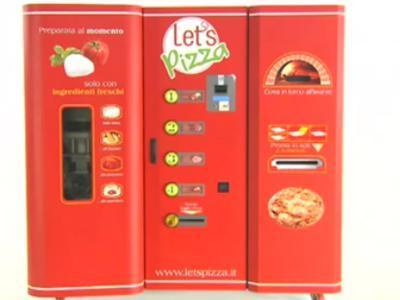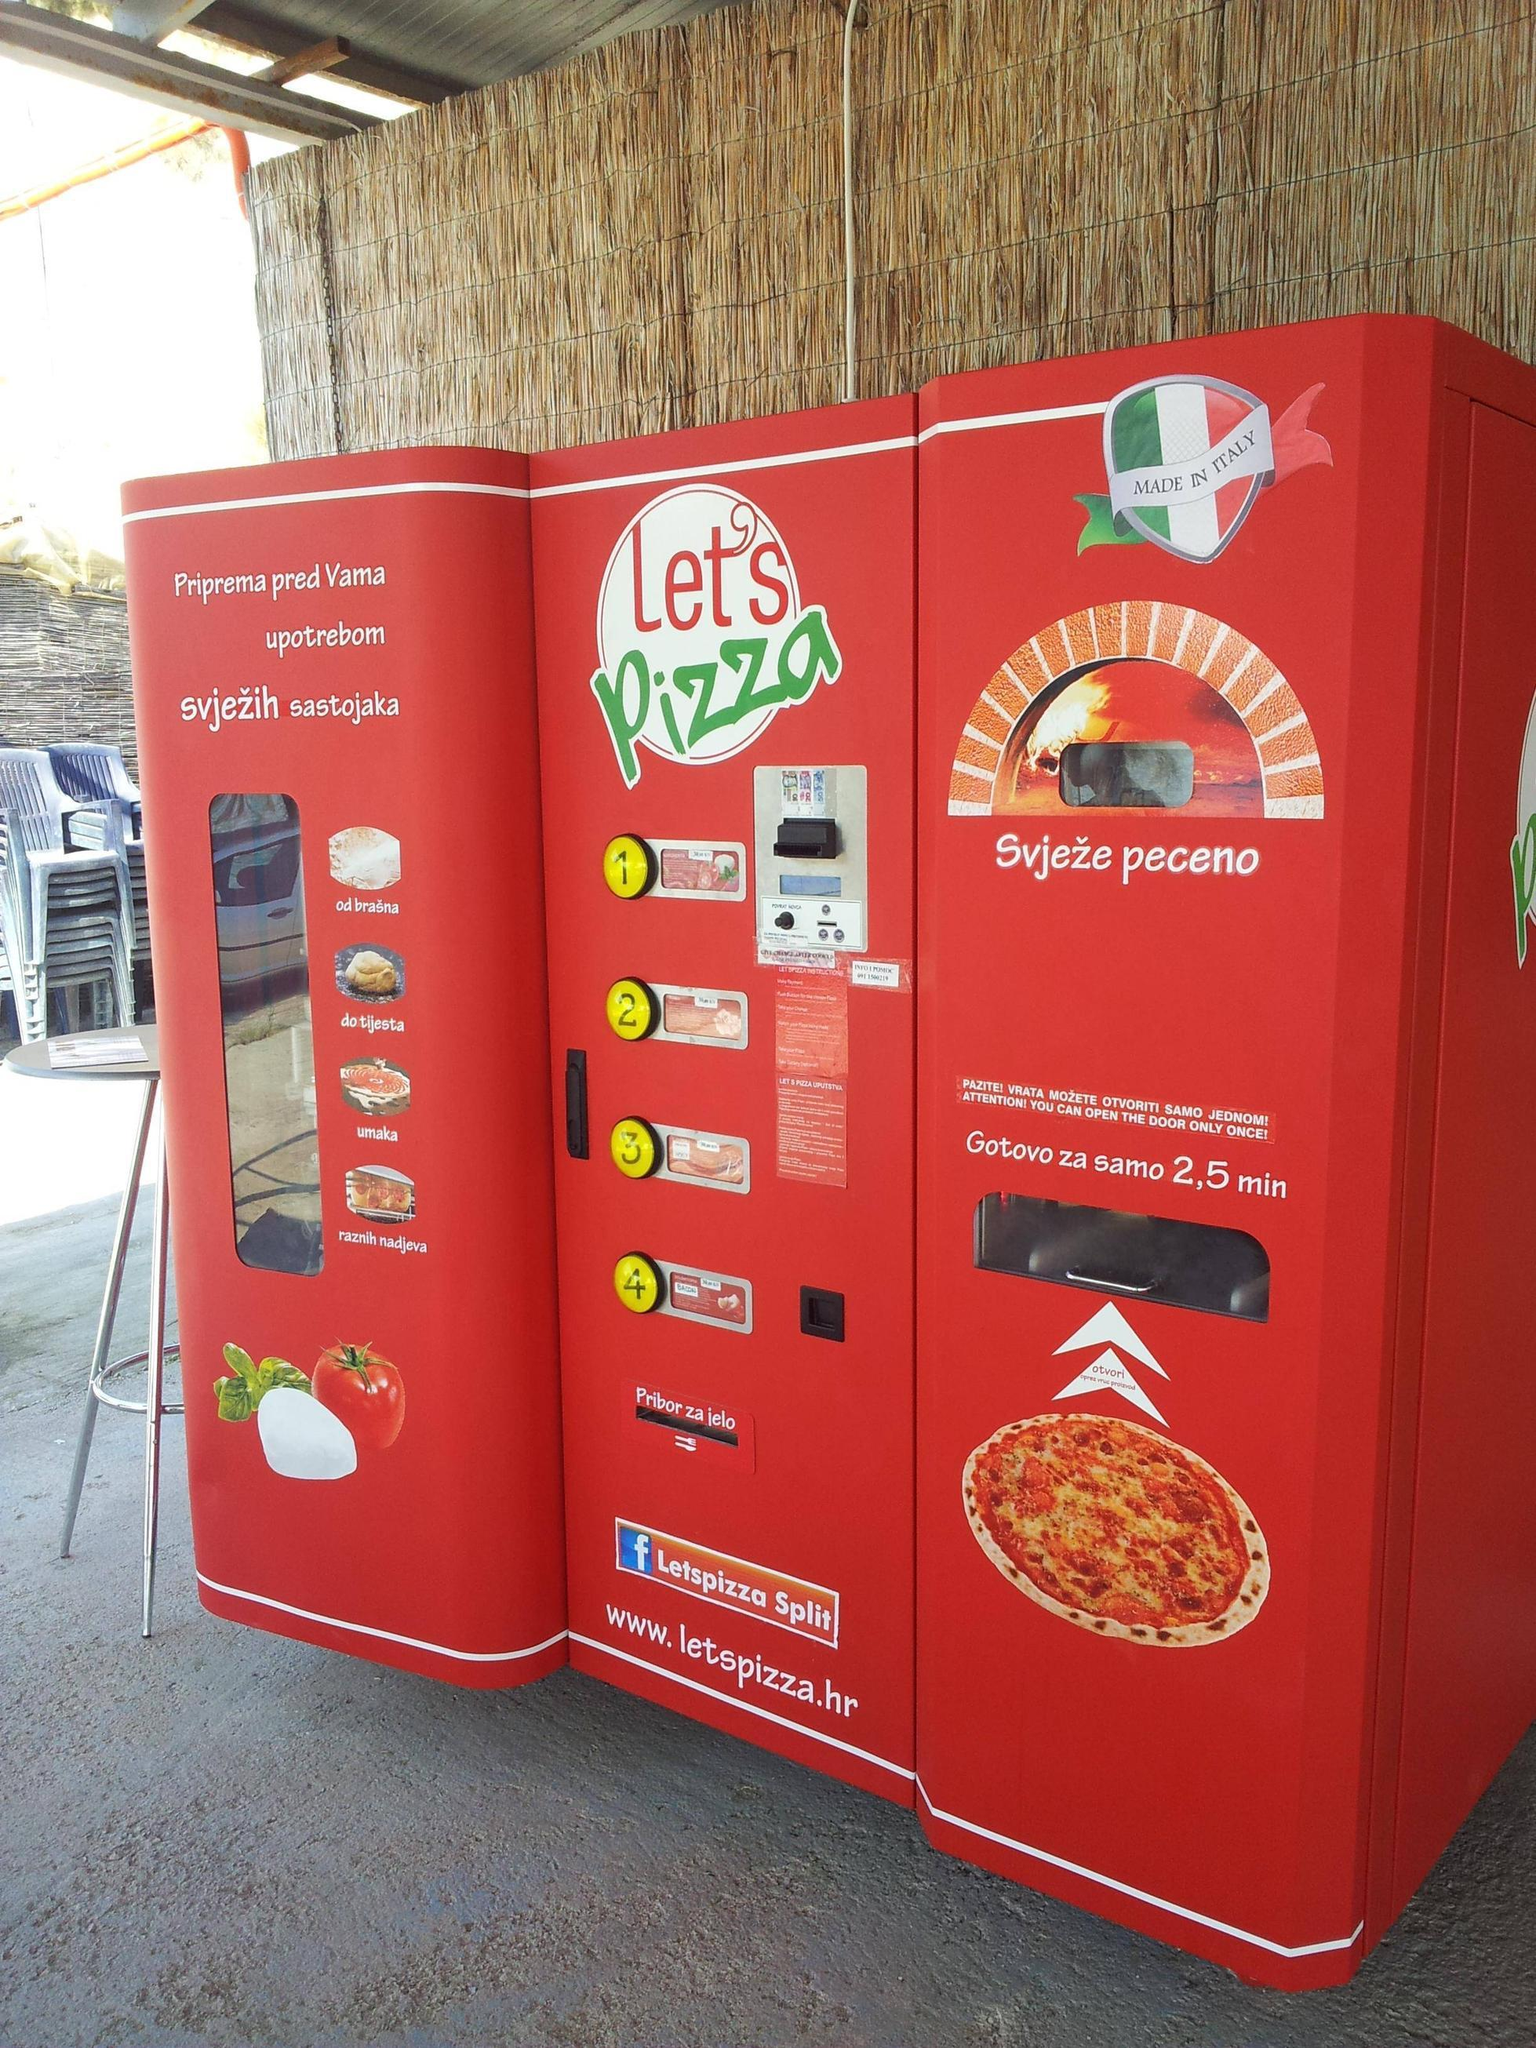The first image is the image on the left, the second image is the image on the right. Given the left and right images, does the statement "Right and left images appear to show the same red pizza vending machine, with the same branding on the front." hold true? Answer yes or no. Yes. 